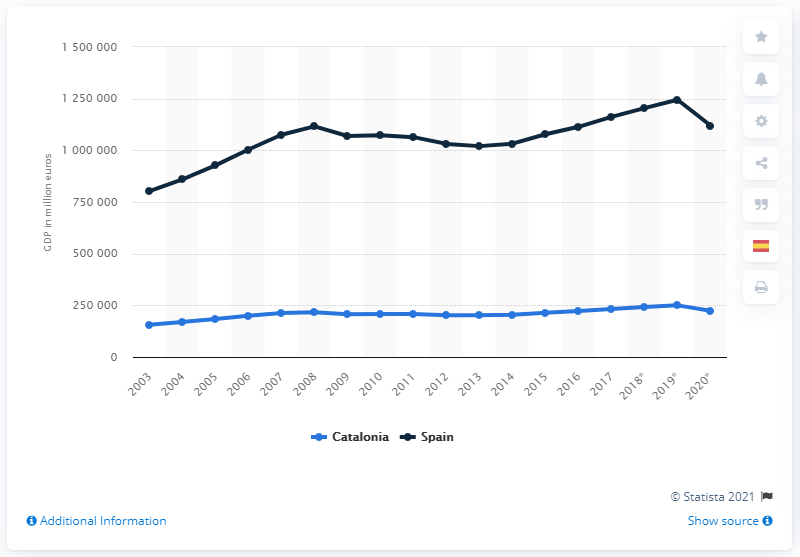Indicate a few pertinent items in this graphic. In 2019, Catalonia's GDP was 249,900 million euros. 